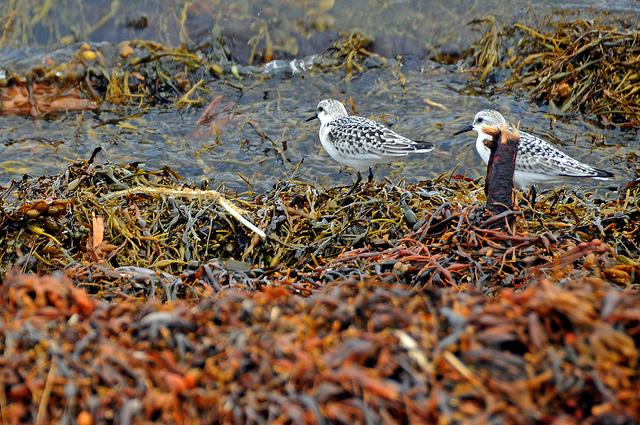What two colors do these birds seem to be?
Quick response, please. White and black. How many birds are there?
Write a very short answer. 2. Is this bird on a beach?
Concise answer only. No. What kind of terrain is this an image of?
Answer briefly. Marsh. 